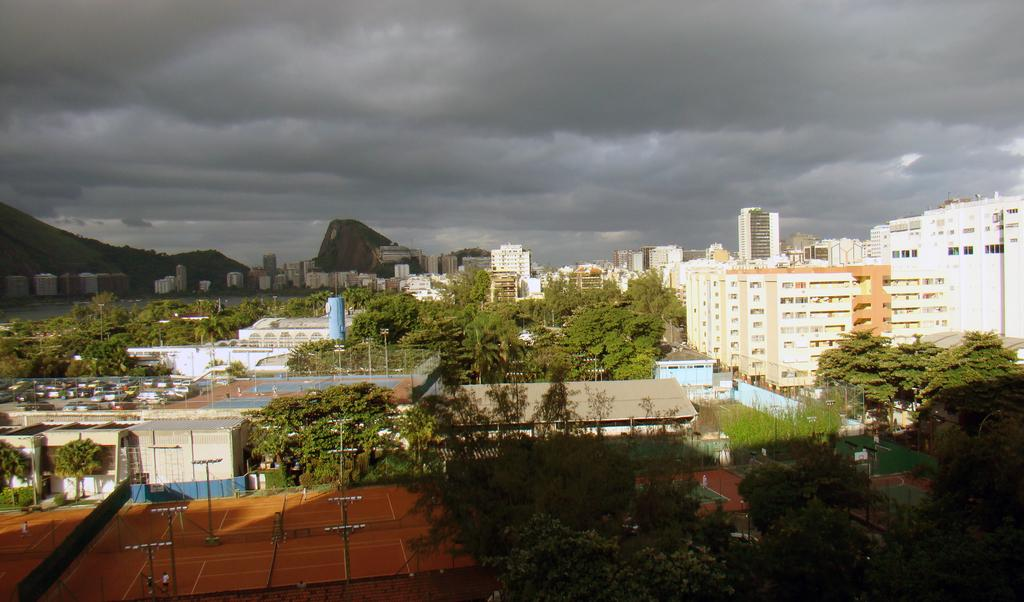What structures can be seen in the image? There are poles, trees, and buildings visible in the image. What type of natural environment is present in the image? There are trees and hills visible in the image. What is the condition of the sky in the background of the image? The sky is cloudy in the background of the image. How many fish can be seen swimming in the image? There are no fish present in the image. What color is the orange in the image? There is no orange present in the image. 